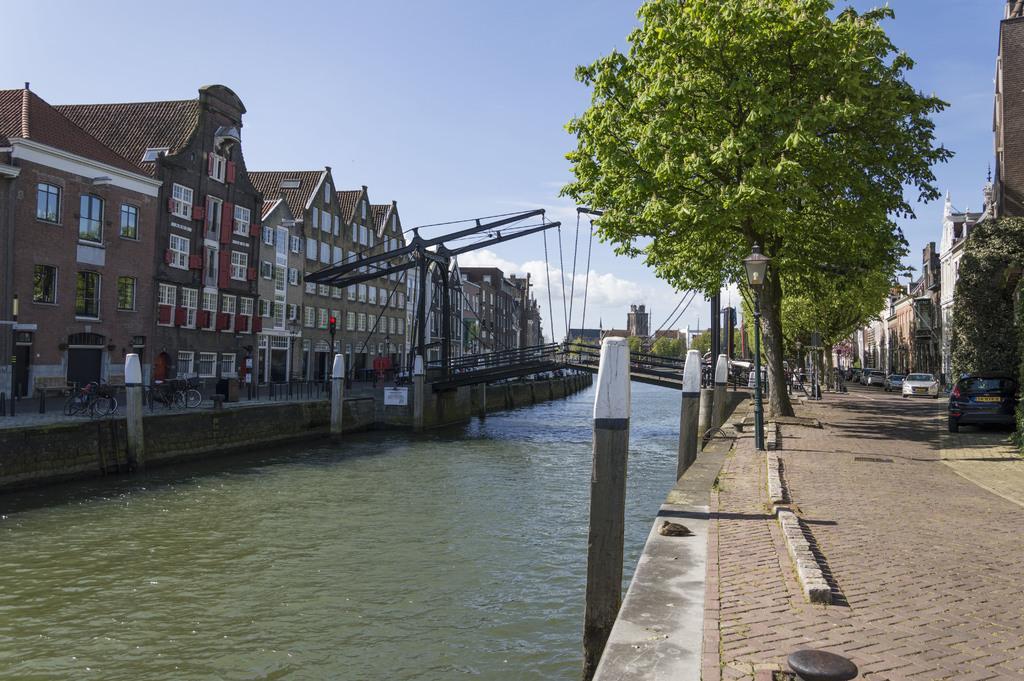How would you summarize this image in a sentence or two? In this image we can see a bridge across the river, barrier poles, bicycles on the floor, buildings, trees, street poles, street lights, motor vehicles on the road and sky with clouds. 